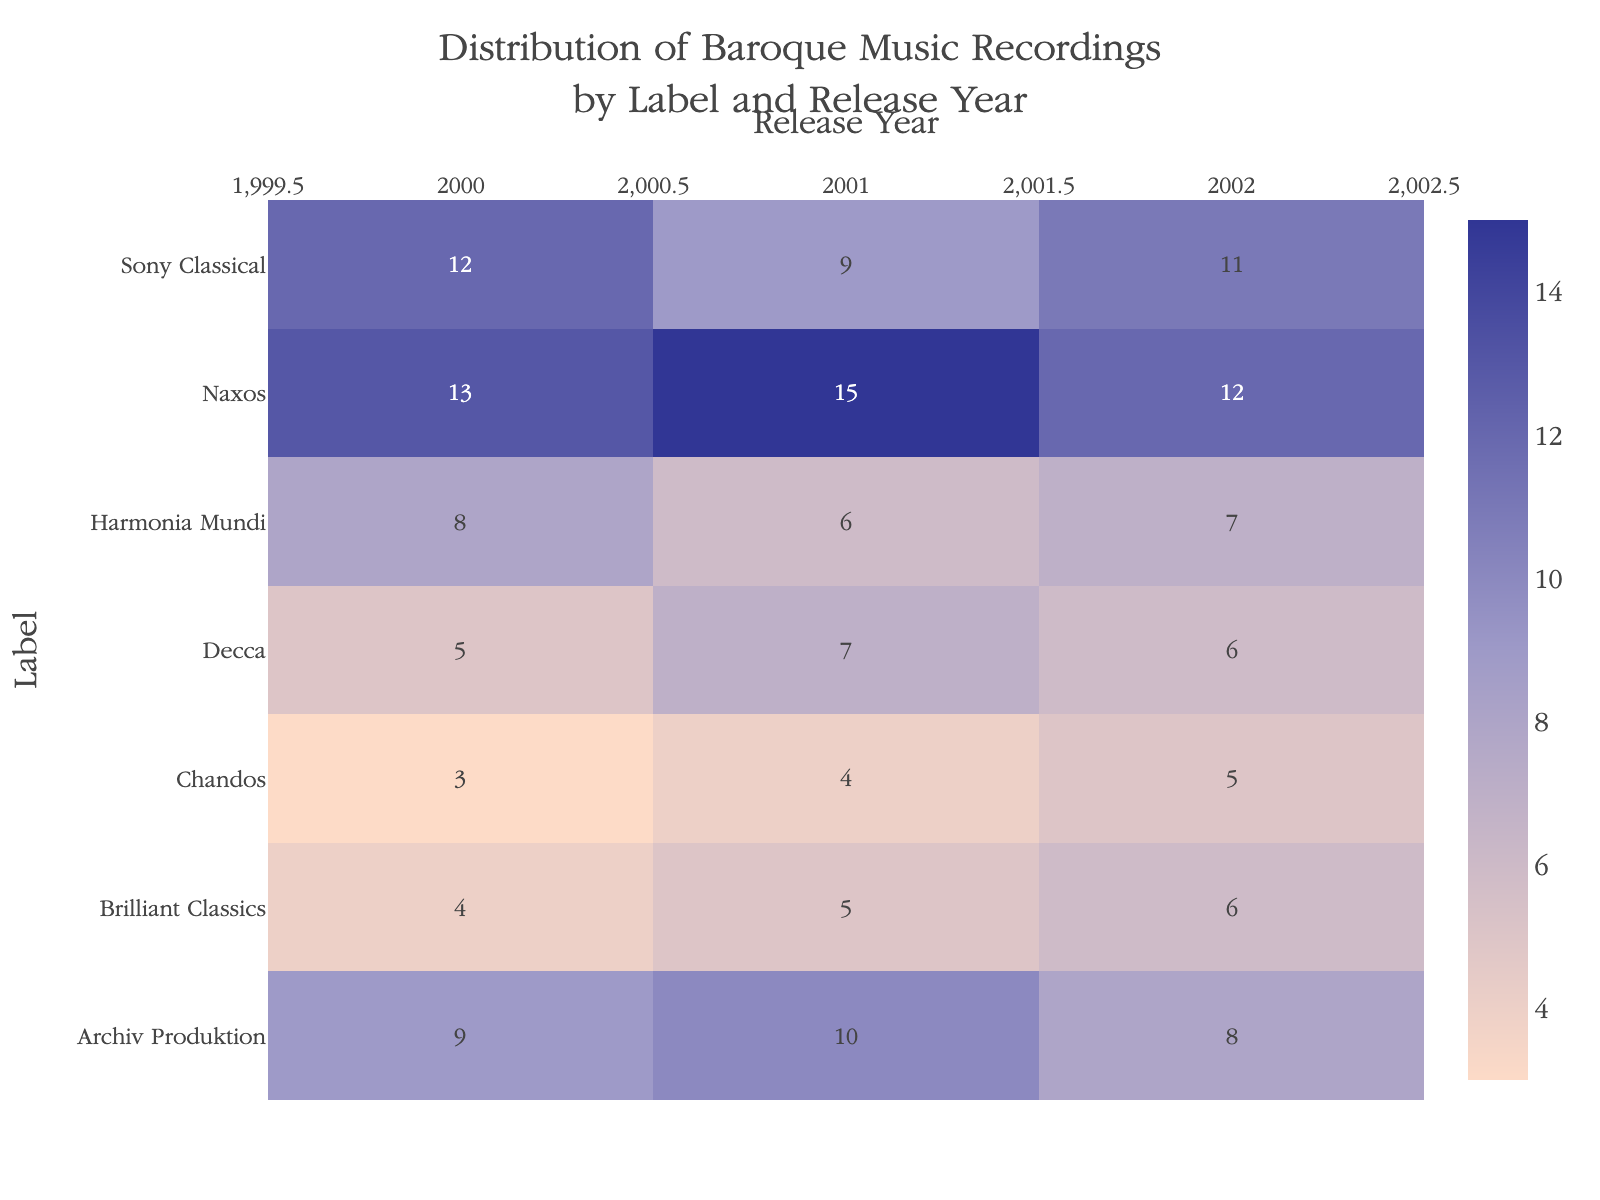Which label has the highest number of recordings in the year 2001? Look at the column for the year 2001 and identify the label with the highest value. Naxos has 15 recordings, which is the highest.
Answer: Naxos What is the total number of Baroque music recordings for Sony Classical across all years? Sum the number of recordings for Sony Classical for each year: 12 (2000) + 9 (2001) + 11 (2002) = 32.
Answer: 32 Which label released more recordings in 2000, Harmonia Mundi or Brilliant Classics? Compare the values for the year 2000: Harmonia Mundi has 8 recordings, and Brilliant Classics has 4.
Answer: Harmonia Mundi What was the average number of recordings by Decca over the three years? Add the recordings for Decca for the years 2000, 2001, and 2002, then divide by 3: (5 + 7 + 6) / 3 = 18 / 3 = 6.
Answer: 6 Among all labels, which one had the least recordings in 2002? Look at the values for the year 2002 and find the smallest number: Brilliant Classics and Chandos both have 5 recordings, which is the least.
Answer: Chandos & Brilliant Classics Is there any label that has an increasing trend in the number of releases from 2000 to 2002? Check each label to see if the values rise each year. No label shows an increasing trend for all three years.
Answer: No What is the average number of recordings across all labels in 2000? Sum the recordings for all labels in 2000 and divide by the number of labels: (5 + 13 + 8 + 9 + 4 + 12 + 3) / 7 = 54 / 7 ≈ 7.71.
Answer: 7.71 Which label showed a decrease in the number of recordings from 2001 to 2002? Compare the values for 2001 and 2002 across labels. Archiv Produktion (10 to 8) and Sony Classical (9 to 8) show a decrease.
Answer: Archiv Produktion & Sony Classical 